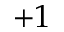<formula> <loc_0><loc_0><loc_500><loc_500>+ 1</formula> 